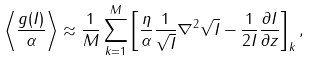<formula> <loc_0><loc_0><loc_500><loc_500>\left \langle \frac { g ( I ) } { \alpha } \right \rangle \approx \frac { 1 } { M } \sum _ { k = 1 } ^ { M } \left [ \frac { \eta } { \alpha } \frac { 1 } { \sqrt { I } } \nabla ^ { 2 } \sqrt { I } - \frac { 1 } { 2 I } \frac { \partial I } { \partial z } \right ] _ { k } ,</formula> 